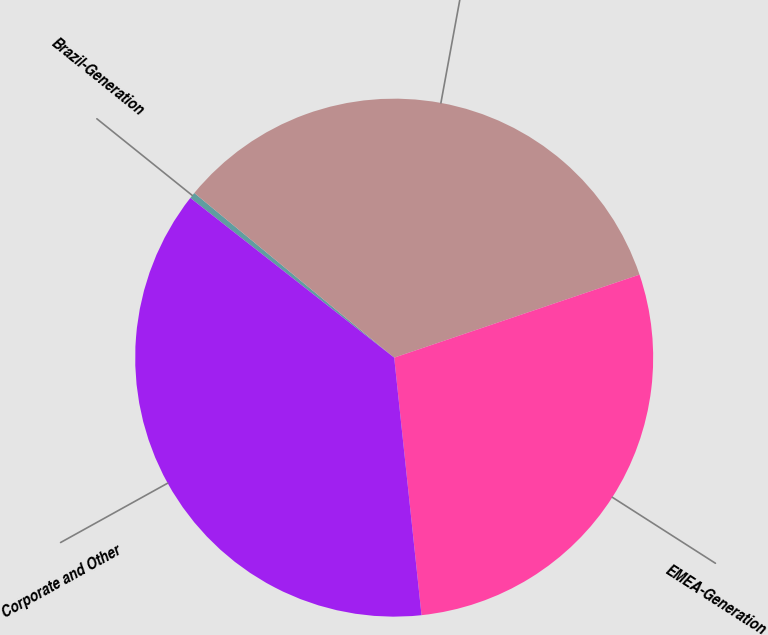Convert chart to OTSL. <chart><loc_0><loc_0><loc_500><loc_500><pie_chart><fcel>Brazil-Generation<fcel>MCAC-Generation<fcel>EMEA-Generation<fcel>Corporate and Other<nl><fcel>0.39%<fcel>33.84%<fcel>28.51%<fcel>37.26%<nl></chart> 